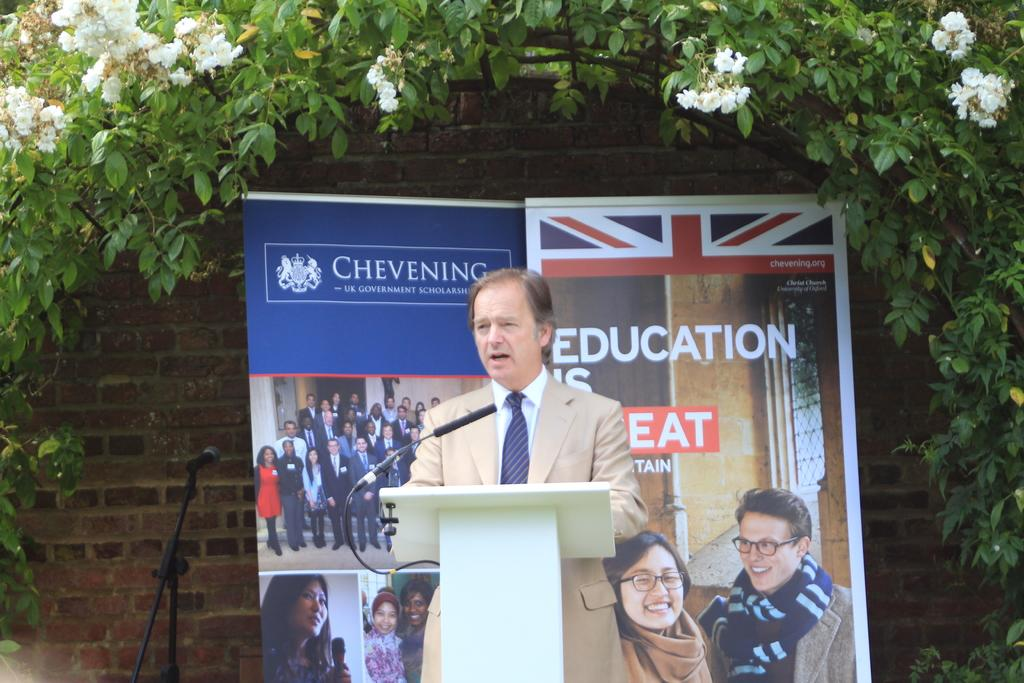Who is the main subject in the image? There is a man in the middle of the image. What is the man wearing? The man is wearing a suit, shirt, and tie. What is in front of the man? There is a podium in front of the man. What is on the podium? There is a microphone on the podium. What can be seen in the background of the image? There are posters, trees, flowers, a wall, and a microphone in the background of the image. What type of letter is being passed around by the bubbles in the image? There are no bubbles or letters present in the image. 